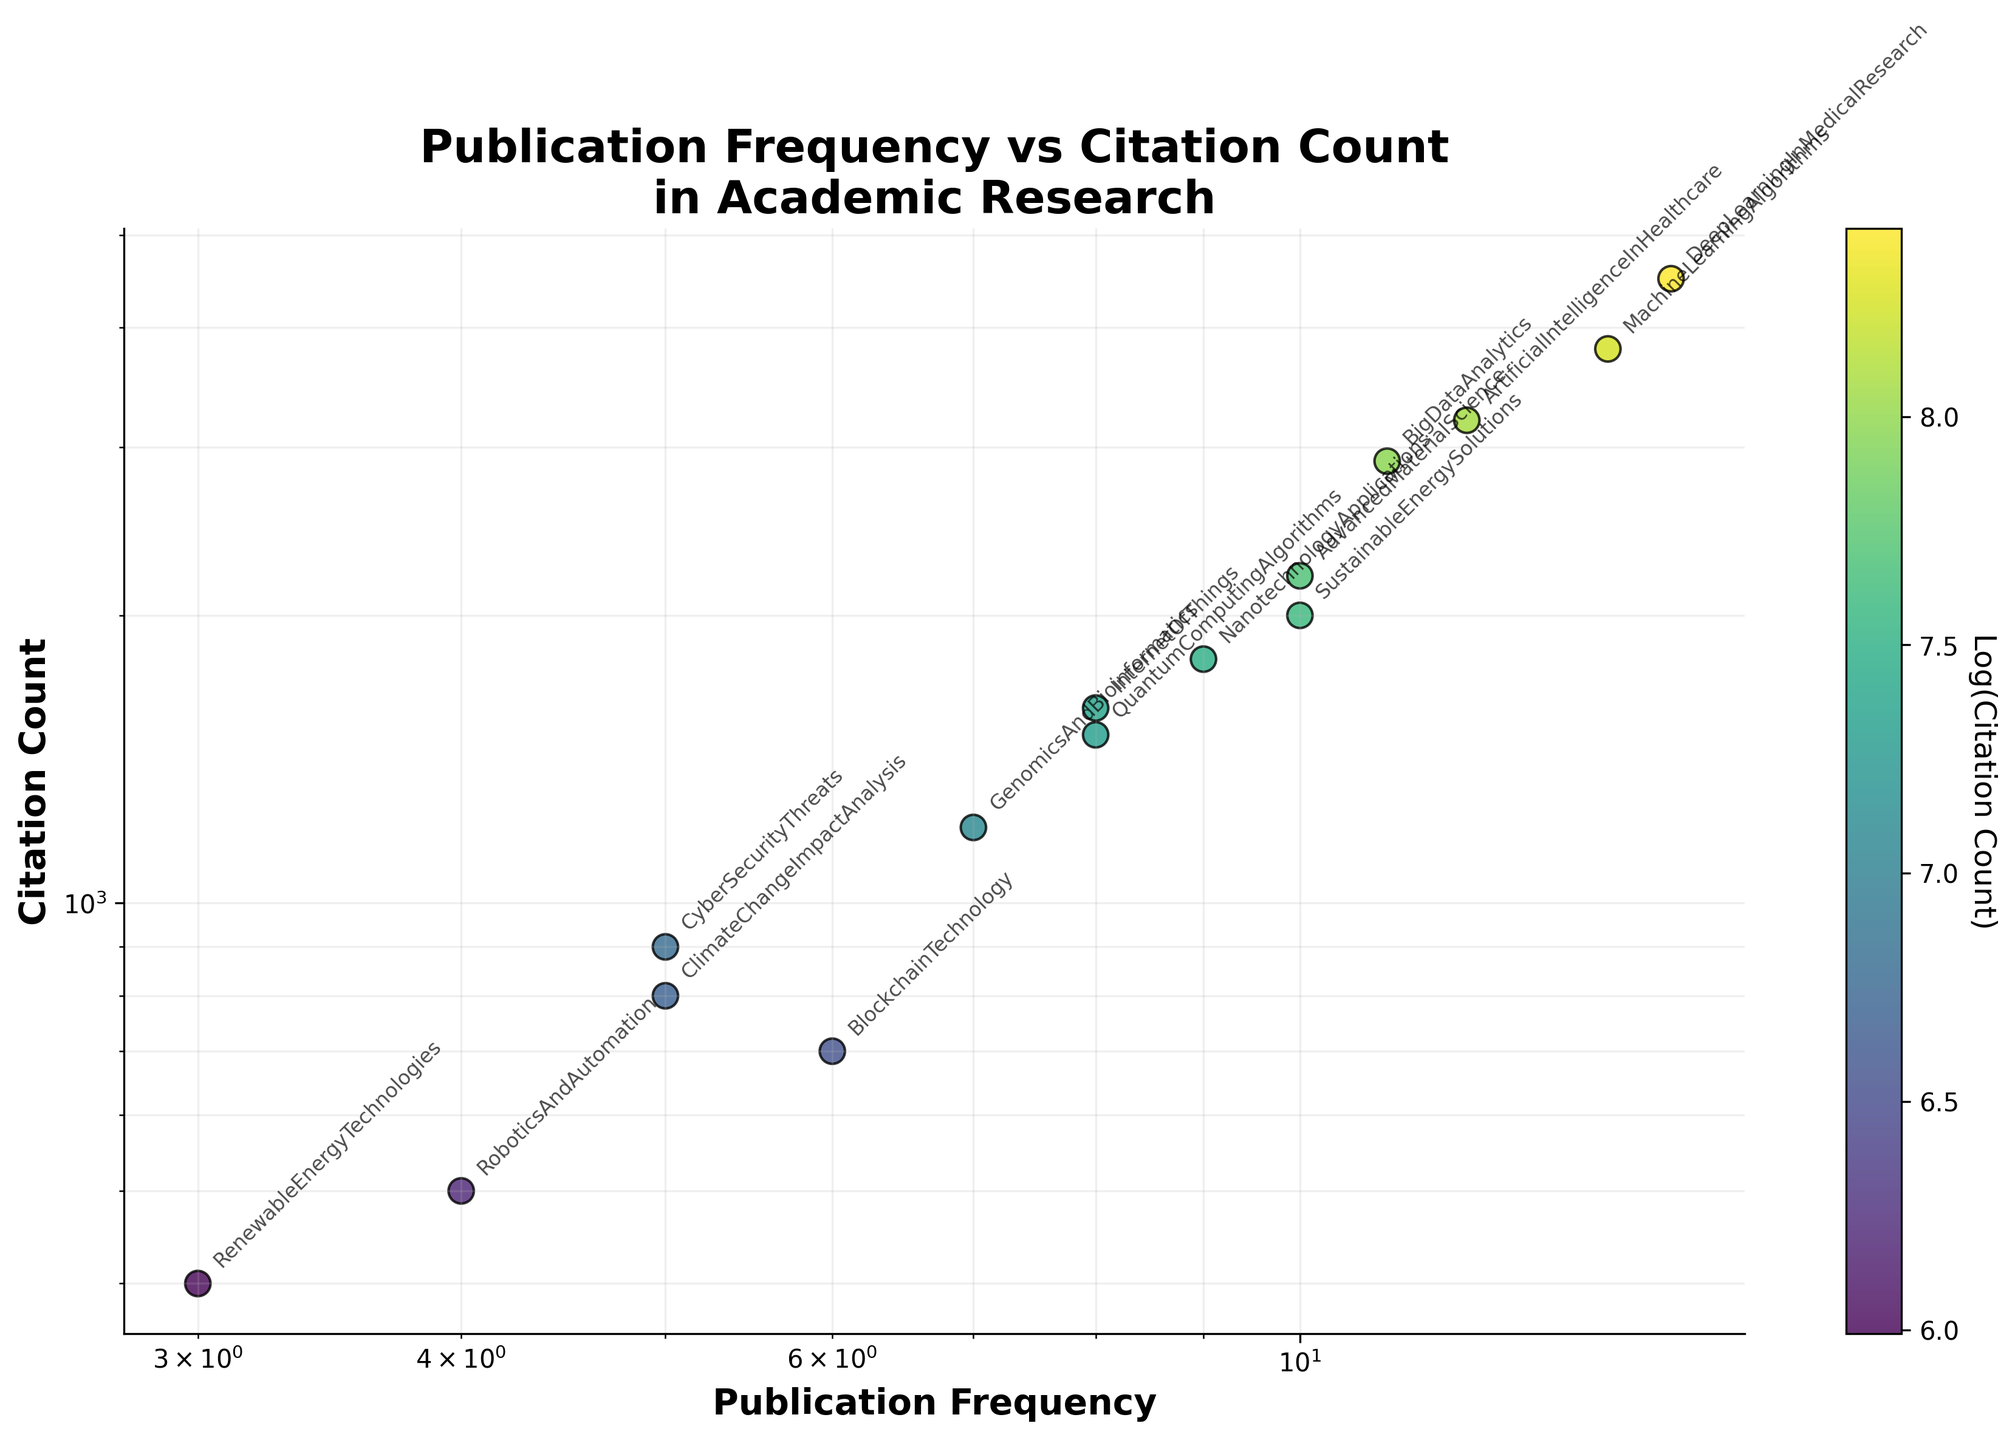What is the title of the figure? The title is displayed at the top of the figure. It reads "Publication Frequency vs Citation Count\nin Academic Research".
Answer: Publication Frequency vs Citation Count in Academic Research How many data points are there in the scatter plot? Each publication title represents a unique data point on the scatter plot. Counting all the publication titles listed yields 15 data points.
Answer: 15 Which publication has the highest citation count? The publication with the highest point on the y-axis has the highest citation count. "DeepLearningInMedicalResearch" is at the top with 4500 citations.
Answer: DeepLearningInMedicalResearch What are the axes labels of the scatter plot? The horizontal axis (x-axis) label is "Publication Frequency", and the vertical axis (y-axis) label is "Citation Count".
Answer: Publication Frequency and Citation Count Which publication has the lowest publication frequency? The publication with the lowest point on the x-axis has the lowest publication frequency. "RenewableEnergyTechnologies" is at the bottom left with a publication frequency of 3.
Answer: RenewableEnergyTechnologies What is the color of the scatter points proportional to? The color of the scatter points is related to the log of the citation count. Darker colors indicate higher log citation counts, and lighter colors indicate lower log citation counts.
Answer: Log(Citation Count) Which publications have a similar citation count of around 900? Looking at the y-axis for values around 900, the publication titles that match are "CyberSecurityThreats" and slightly above it "ClimateChangeImpactAnalysis" which is at 800.
Answer: CyberSecurityThreats and ClimateChangeImpactAnalysis What is the relationship between "MachineLearningAlgorithms" and "DeepLearningInMedicalResearch" in terms of publication frequency and citation count? "DeepLearningInMedicalResearch" has a publication frequency of 15 and a citation count of 4500. "MachineLearningAlgorithms" has a slightly lower frequency of 14 and a citation count of 3800. Both have high publication frequencies and citation counts, with "DeepLearningInMedicalResearch" being higher in both aspects.
Answer: "MachineLearningAlgorithms" has a lower publication frequency and citation count compared to "DeepLearningInMedicalResearch" How does "QuantumComputingAlgorithms" compare with "BlockchainTechnology" in terms of their performance based on citation count and publication frequency? "QuantumComputingAlgorithms" has a publication frequency of 8 and citation count of 1500, while "BlockchainTechnology" has a publication frequency of 6 and citation count of 700. Thus, "QuantumComputingAlgorithms" outperforms "BlockchainTechnology" in both citation count and publication frequency.
Answer: "QuantumComputingAlgorithms" outperforms "BlockchainTechnology" What is the median publication frequency among the given data points? Ordering the publication frequencies: 3, 4, 5, 5, 6, 7, 8, 8, 9, 10, 10, 11, 12, 14, 15. The median publication frequency, being the middle value in this ordered list, is 8 (the 8th term in a sorted list of 15 terms).
Answer: 8 